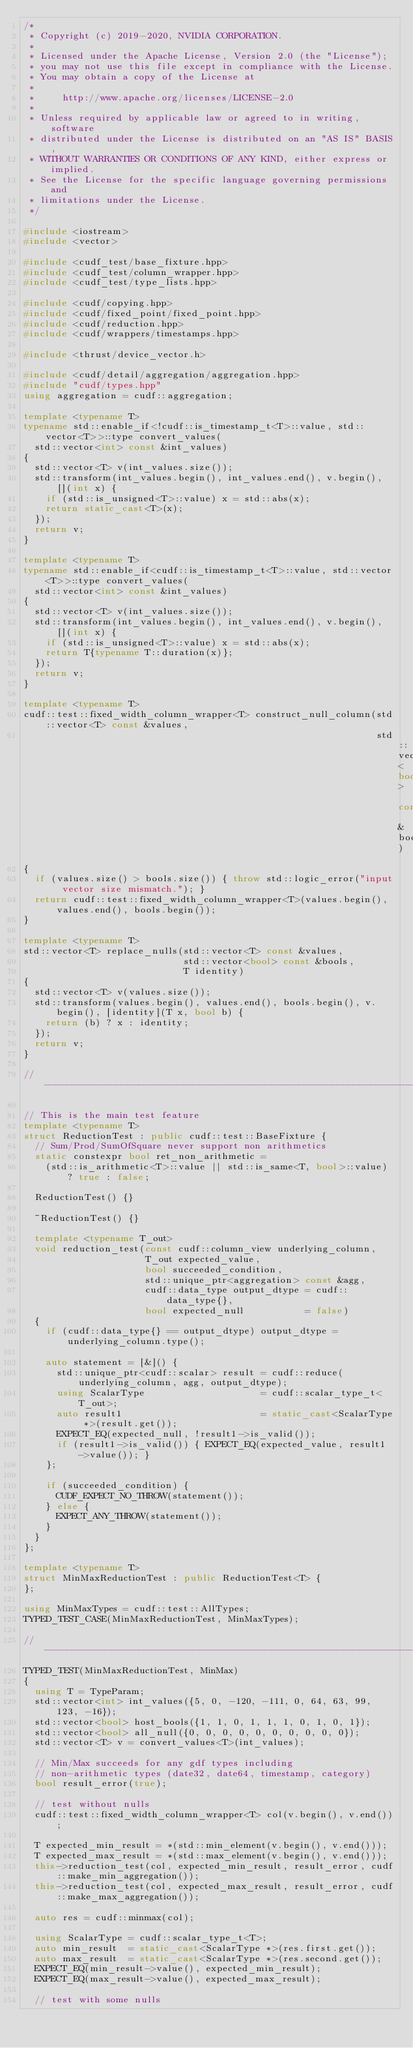Convert code to text. <code><loc_0><loc_0><loc_500><loc_500><_C++_>/*
 * Copyright (c) 2019-2020, NVIDIA CORPORATION.
 *
 * Licensed under the Apache License, Version 2.0 (the "License");
 * you may not use this file except in compliance with the License.
 * You may obtain a copy of the License at
 *
 *     http://www.apache.org/licenses/LICENSE-2.0
 *
 * Unless required by applicable law or agreed to in writing, software
 * distributed under the License is distributed on an "AS IS" BASIS,
 * WITHOUT WARRANTIES OR CONDITIONS OF ANY KIND, either express or implied.
 * See the License for the specific language governing permissions and
 * limitations under the License.
 */

#include <iostream>
#include <vector>

#include <cudf_test/base_fixture.hpp>
#include <cudf_test/column_wrapper.hpp>
#include <cudf_test/type_lists.hpp>

#include <cudf/copying.hpp>
#include <cudf/fixed_point/fixed_point.hpp>
#include <cudf/reduction.hpp>
#include <cudf/wrappers/timestamps.hpp>

#include <thrust/device_vector.h>

#include <cudf/detail/aggregation/aggregation.hpp>
#include "cudf/types.hpp"
using aggregation = cudf::aggregation;

template <typename T>
typename std::enable_if<!cudf::is_timestamp_t<T>::value, std::vector<T>>::type convert_values(
  std::vector<int> const &int_values)
{
  std::vector<T> v(int_values.size());
  std::transform(int_values.begin(), int_values.end(), v.begin(), [](int x) {
    if (std::is_unsigned<T>::value) x = std::abs(x);
    return static_cast<T>(x);
  });
  return v;
}

template <typename T>
typename std::enable_if<cudf::is_timestamp_t<T>::value, std::vector<T>>::type convert_values(
  std::vector<int> const &int_values)
{
  std::vector<T> v(int_values.size());
  std::transform(int_values.begin(), int_values.end(), v.begin(), [](int x) {
    if (std::is_unsigned<T>::value) x = std::abs(x);
    return T{typename T::duration(x)};
  });
  return v;
}

template <typename T>
cudf::test::fixed_width_column_wrapper<T> construct_null_column(std::vector<T> const &values,
                                                                std::vector<bool> const &bools)
{
  if (values.size() > bools.size()) { throw std::logic_error("input vector size mismatch."); }
  return cudf::test::fixed_width_column_wrapper<T>(values.begin(), values.end(), bools.begin());
}

template <typename T>
std::vector<T> replace_nulls(std::vector<T> const &values,
                             std::vector<bool> const &bools,
                             T identity)
{
  std::vector<T> v(values.size());
  std::transform(values.begin(), values.end(), bools.begin(), v.begin(), [identity](T x, bool b) {
    return (b) ? x : identity;
  });
  return v;
}

// ------------------------------------------------------------------------

// This is the main test feature
template <typename T>
struct ReductionTest : public cudf::test::BaseFixture {
  // Sum/Prod/SumOfSquare never support non arithmetics
  static constexpr bool ret_non_arithmetic =
    (std::is_arithmetic<T>::value || std::is_same<T, bool>::value) ? true : false;

  ReductionTest() {}

  ~ReductionTest() {}

  template <typename T_out>
  void reduction_test(const cudf::column_view underlying_column,
                      T_out expected_value,
                      bool succeeded_condition,
                      std::unique_ptr<aggregation> const &agg,
                      cudf::data_type output_dtype = cudf::data_type{},
                      bool expected_null           = false)
  {
    if (cudf::data_type{} == output_dtype) output_dtype = underlying_column.type();

    auto statement = [&]() {
      std::unique_ptr<cudf::scalar> result = cudf::reduce(underlying_column, agg, output_dtype);
      using ScalarType                     = cudf::scalar_type_t<T_out>;
      auto result1                         = static_cast<ScalarType *>(result.get());
      EXPECT_EQ(expected_null, !result1->is_valid());
      if (result1->is_valid()) { EXPECT_EQ(expected_value, result1->value()); }
    };

    if (succeeded_condition) {
      CUDF_EXPECT_NO_THROW(statement());
    } else {
      EXPECT_ANY_THROW(statement());
    }
  }
};

template <typename T>
struct MinMaxReductionTest : public ReductionTest<T> {
};

using MinMaxTypes = cudf::test::AllTypes;
TYPED_TEST_CASE(MinMaxReductionTest, MinMaxTypes);

// ------------------------------------------------------------------------
TYPED_TEST(MinMaxReductionTest, MinMax)
{
  using T = TypeParam;
  std::vector<int> int_values({5, 0, -120, -111, 0, 64, 63, 99, 123, -16});
  std::vector<bool> host_bools({1, 1, 0, 1, 1, 1, 0, 1, 0, 1});
  std::vector<bool> all_null({0, 0, 0, 0, 0, 0, 0, 0, 0, 0});
  std::vector<T> v = convert_values<T>(int_values);

  // Min/Max succeeds for any gdf types including
  // non-arithmetic types (date32, date64, timestamp, category)
  bool result_error(true);

  // test without nulls
  cudf::test::fixed_width_column_wrapper<T> col(v.begin(), v.end());

  T expected_min_result = *(std::min_element(v.begin(), v.end()));
  T expected_max_result = *(std::max_element(v.begin(), v.end()));
  this->reduction_test(col, expected_min_result, result_error, cudf::make_min_aggregation());
  this->reduction_test(col, expected_max_result, result_error, cudf::make_max_aggregation());

  auto res = cudf::minmax(col);

  using ScalarType = cudf::scalar_type_t<T>;
  auto min_result  = static_cast<ScalarType *>(res.first.get());
  auto max_result  = static_cast<ScalarType *>(res.second.get());
  EXPECT_EQ(min_result->value(), expected_min_result);
  EXPECT_EQ(max_result->value(), expected_max_result);

  // test with some nulls</code> 